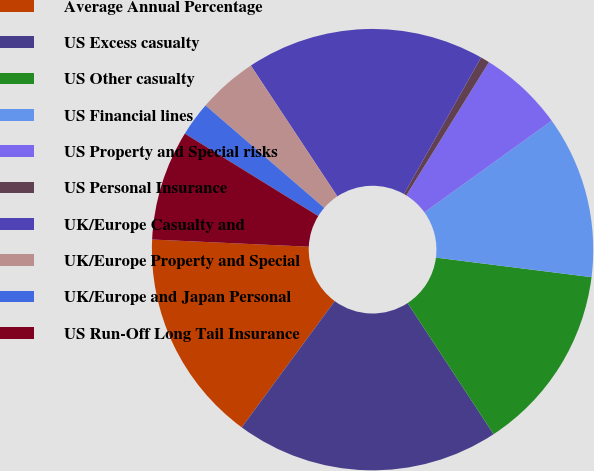<chart> <loc_0><loc_0><loc_500><loc_500><pie_chart><fcel>Average Annual Percentage<fcel>US Excess casualty<fcel>US Other casualty<fcel>US Financial lines<fcel>US Property and Special risks<fcel>US Personal Insurance<fcel>UK/Europe Casualty and<fcel>UK/Europe Property and Special<fcel>UK/Europe and Japan Personal<fcel>US Run-Off Long Tail Insurance<nl><fcel>15.63%<fcel>19.34%<fcel>13.77%<fcel>11.92%<fcel>6.23%<fcel>0.66%<fcel>17.48%<fcel>4.37%<fcel>2.52%<fcel>8.08%<nl></chart> 